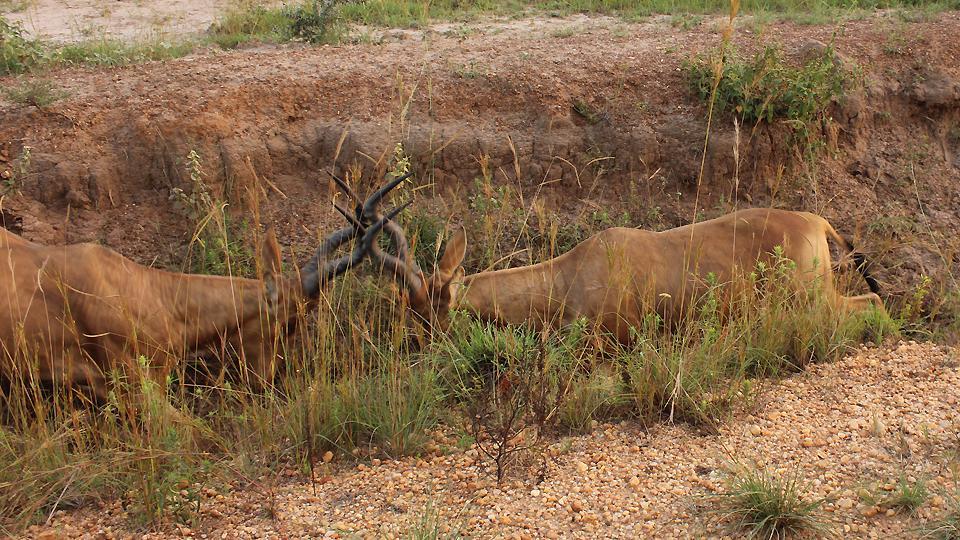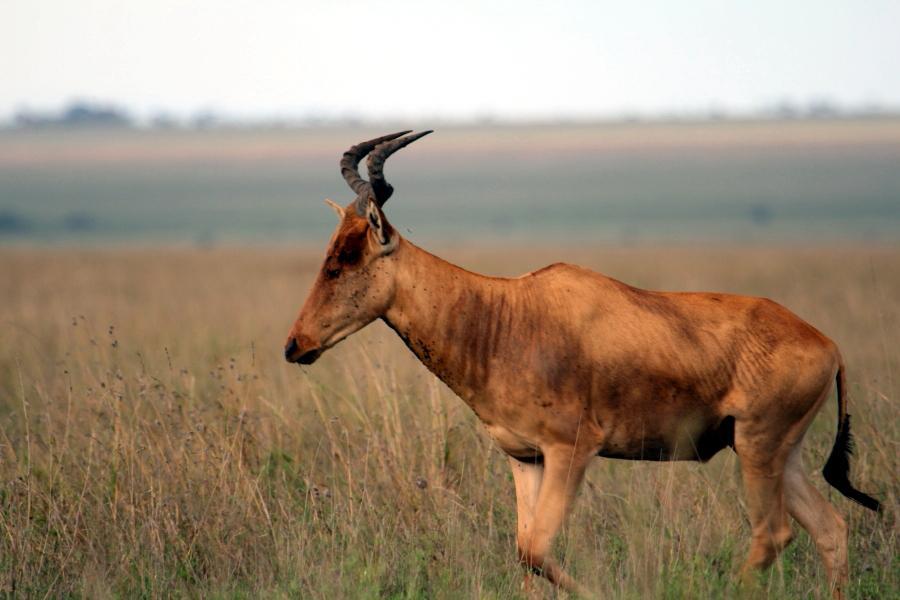The first image is the image on the left, the second image is the image on the right. Analyze the images presented: Is the assertion "Each image contains a single horned animal in the foreground, and the animal's body is turned leftward." valid? Answer yes or no. No. The first image is the image on the left, the second image is the image on the right. For the images shown, is this caption "There are two antelopes, both facing left." true? Answer yes or no. No. 